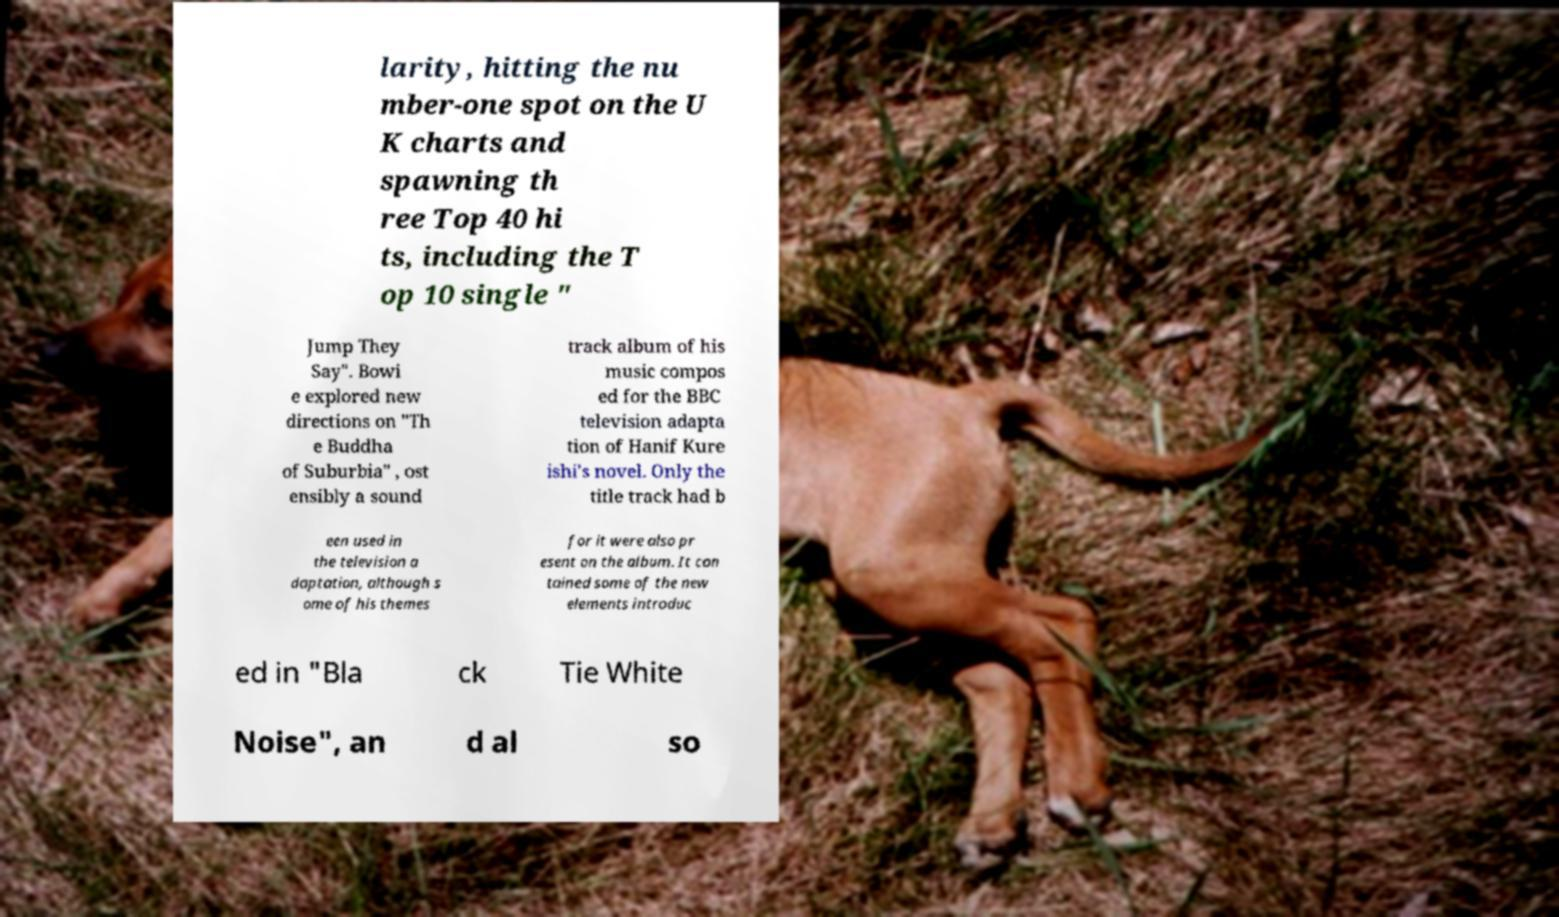What messages or text are displayed in this image? I need them in a readable, typed format. larity, hitting the nu mber-one spot on the U K charts and spawning th ree Top 40 hi ts, including the T op 10 single " Jump They Say". Bowi e explored new directions on "Th e Buddha of Suburbia" , ost ensibly a sound track album of his music compos ed for the BBC television adapta tion of Hanif Kure ishi's novel. Only the title track had b een used in the television a daptation, although s ome of his themes for it were also pr esent on the album. It con tained some of the new elements introduc ed in "Bla ck Tie White Noise", an d al so 